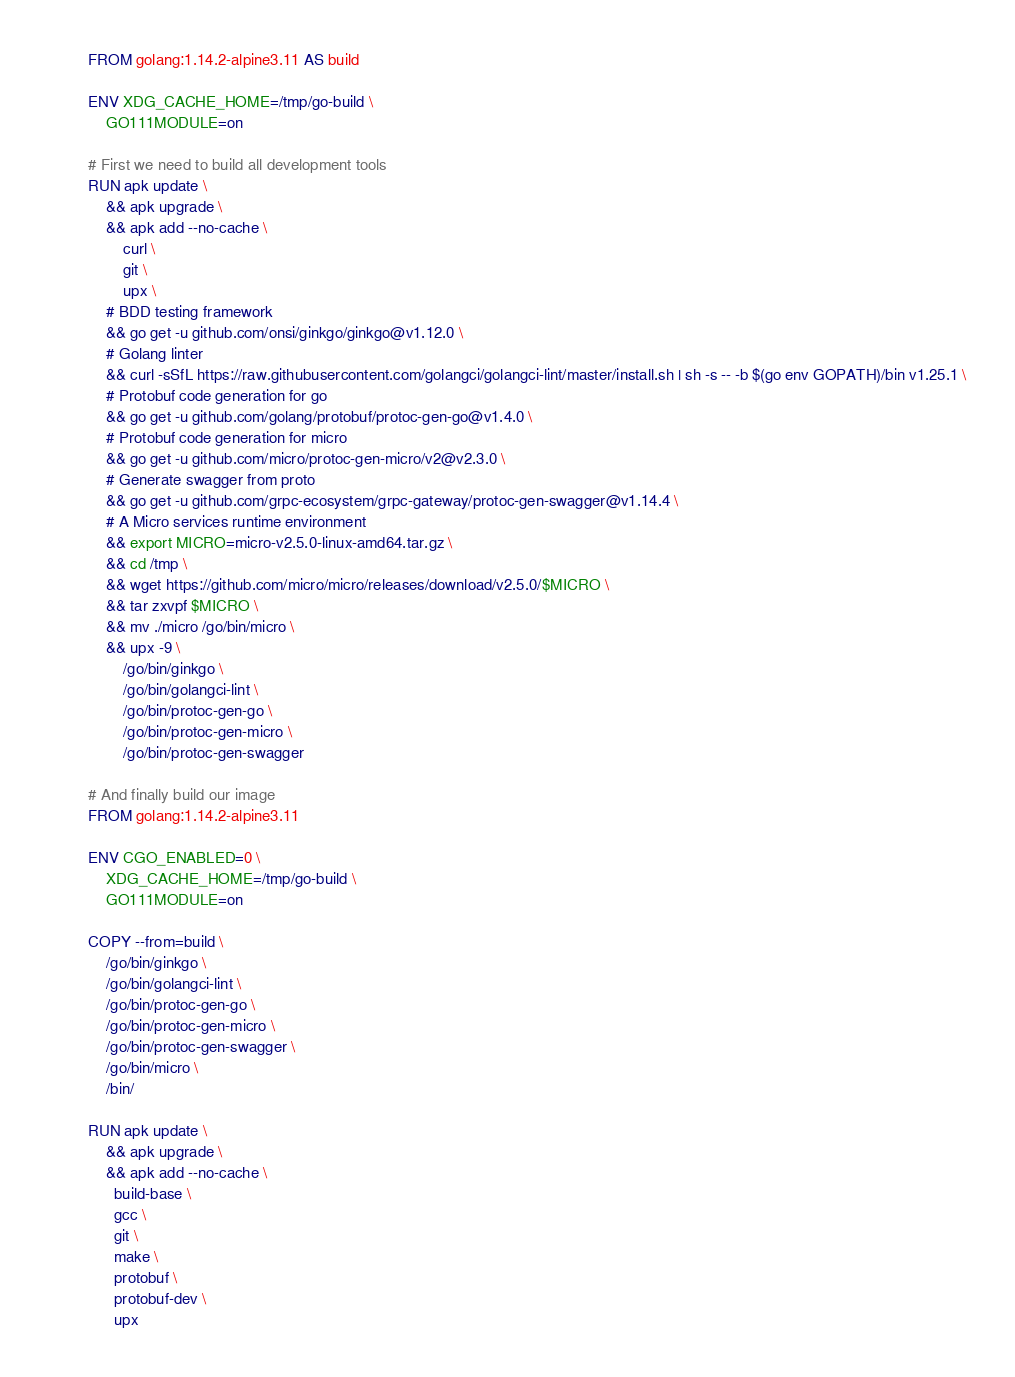<code> <loc_0><loc_0><loc_500><loc_500><_Dockerfile_>FROM golang:1.14.2-alpine3.11 AS build

ENV XDG_CACHE_HOME=/tmp/go-build \
    GO111MODULE=on

# First we need to build all development tools
RUN apk update \
    && apk upgrade \
    && apk add --no-cache \
        curl \
        git \
        upx \
    # BDD testing framework
    && go get -u github.com/onsi/ginkgo/ginkgo@v1.12.0 \
    # Golang linter
    && curl -sSfL https://raw.githubusercontent.com/golangci/golangci-lint/master/install.sh | sh -s -- -b $(go env GOPATH)/bin v1.25.1 \
    # Protobuf code generation for go
    && go get -u github.com/golang/protobuf/protoc-gen-go@v1.4.0 \
    # Protobuf code generation for micro
    && go get -u github.com/micro/protoc-gen-micro/v2@v2.3.0 \
    # Generate swagger from proto
    && go get -u github.com/grpc-ecosystem/grpc-gateway/protoc-gen-swagger@v1.14.4 \
    # A Micro services runtime environment
    && export MICRO=micro-v2.5.0-linux-amd64.tar.gz \
    && cd /tmp \
    && wget https://github.com/micro/micro/releases/download/v2.5.0/$MICRO \
    && tar zxvpf $MICRO \
    && mv ./micro /go/bin/micro \
    && upx -9 \
        /go/bin/ginkgo \
        /go/bin/golangci-lint \
        /go/bin/protoc-gen-go \
        /go/bin/protoc-gen-micro \
        /go/bin/protoc-gen-swagger

# And finally build our image
FROM golang:1.14.2-alpine3.11

ENV CGO_ENABLED=0 \
    XDG_CACHE_HOME=/tmp/go-build \
    GO111MODULE=on

COPY --from=build \
    /go/bin/ginkgo \
    /go/bin/golangci-lint \
    /go/bin/protoc-gen-go \
    /go/bin/protoc-gen-micro \
    /go/bin/protoc-gen-swagger \
    /go/bin/micro \
    /bin/

RUN apk update \
    && apk upgrade \
    && apk add --no-cache \
      build-base \
      gcc \
      git \
      make \
      protobuf \
      protobuf-dev \
      upx
</code> 